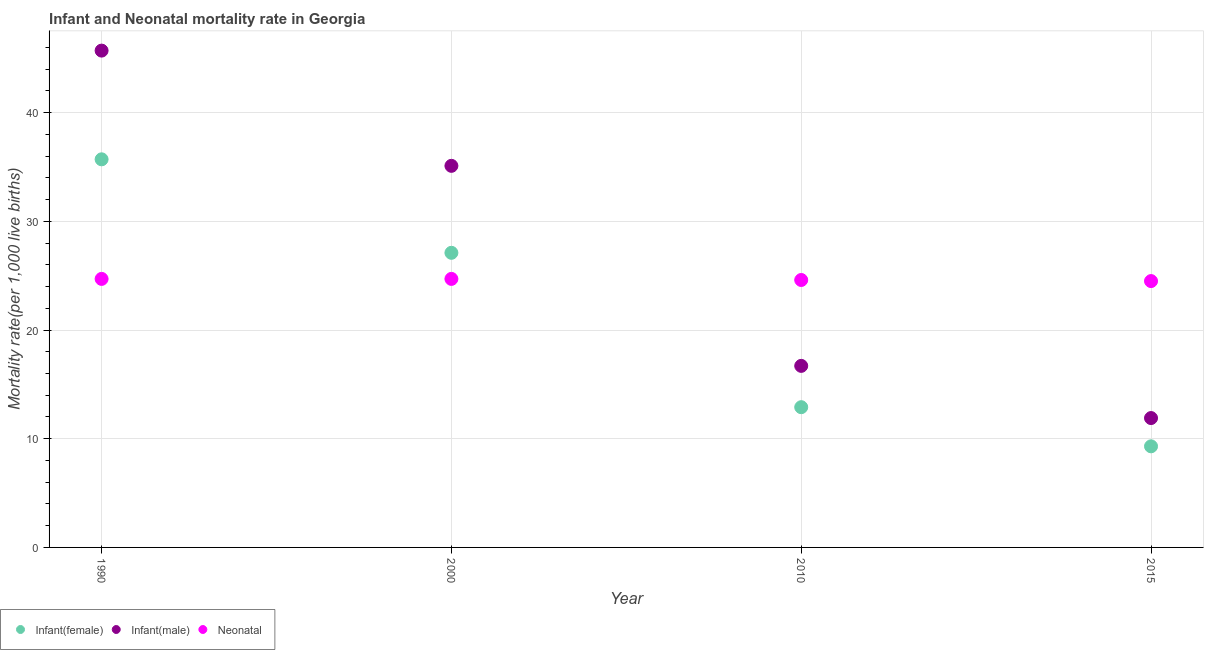Is the number of dotlines equal to the number of legend labels?
Your answer should be compact. Yes. What is the infant mortality rate(female) in 2000?
Give a very brief answer. 27.1. Across all years, what is the maximum neonatal mortality rate?
Offer a terse response. 24.7. In which year was the neonatal mortality rate minimum?
Provide a short and direct response. 2015. What is the total infant mortality rate(male) in the graph?
Ensure brevity in your answer.  109.4. What is the difference between the infant mortality rate(male) in 1990 and that in 2010?
Ensure brevity in your answer.  29. What is the difference between the neonatal mortality rate in 1990 and the infant mortality rate(female) in 2015?
Your answer should be compact. 15.4. What is the average infant mortality rate(male) per year?
Give a very brief answer. 27.35. In the year 1990, what is the difference between the infant mortality rate(male) and infant mortality rate(female)?
Offer a very short reply. 10. What is the ratio of the infant mortality rate(female) in 1990 to that in 2010?
Your response must be concise. 2.77. Is the infant mortality rate(female) in 2010 less than that in 2015?
Your answer should be very brief. No. What is the difference between the highest and the second highest infant mortality rate(female)?
Offer a very short reply. 8.6. What is the difference between the highest and the lowest infant mortality rate(female)?
Keep it short and to the point. 26.4. Is it the case that in every year, the sum of the infant mortality rate(female) and infant mortality rate(male) is greater than the neonatal mortality rate?
Give a very brief answer. No. Does the neonatal mortality rate monotonically increase over the years?
Keep it short and to the point. No. Is the infant mortality rate(female) strictly less than the infant mortality rate(male) over the years?
Offer a terse response. Yes. What is the difference between two consecutive major ticks on the Y-axis?
Keep it short and to the point. 10. Are the values on the major ticks of Y-axis written in scientific E-notation?
Make the answer very short. No. Does the graph contain any zero values?
Give a very brief answer. No. Where does the legend appear in the graph?
Provide a short and direct response. Bottom left. What is the title of the graph?
Provide a succinct answer. Infant and Neonatal mortality rate in Georgia. What is the label or title of the X-axis?
Provide a short and direct response. Year. What is the label or title of the Y-axis?
Give a very brief answer. Mortality rate(per 1,0 live births). What is the Mortality rate(per 1,000 live births) in Infant(female) in 1990?
Make the answer very short. 35.7. What is the Mortality rate(per 1,000 live births) in Infant(male) in 1990?
Your answer should be compact. 45.7. What is the Mortality rate(per 1,000 live births) in Neonatal  in 1990?
Your answer should be compact. 24.7. What is the Mortality rate(per 1,000 live births) in Infant(female) in 2000?
Your response must be concise. 27.1. What is the Mortality rate(per 1,000 live births) of Infant(male) in 2000?
Your answer should be very brief. 35.1. What is the Mortality rate(per 1,000 live births) in Neonatal  in 2000?
Your response must be concise. 24.7. What is the Mortality rate(per 1,000 live births) of Infant(female) in 2010?
Offer a terse response. 12.9. What is the Mortality rate(per 1,000 live births) in Infant(male) in 2010?
Provide a short and direct response. 16.7. What is the Mortality rate(per 1,000 live births) of Neonatal  in 2010?
Offer a very short reply. 24.6. What is the Mortality rate(per 1,000 live births) of Infant(male) in 2015?
Keep it short and to the point. 11.9. Across all years, what is the maximum Mortality rate(per 1,000 live births) of Infant(female)?
Your answer should be compact. 35.7. Across all years, what is the maximum Mortality rate(per 1,000 live births) in Infant(male)?
Ensure brevity in your answer.  45.7. Across all years, what is the maximum Mortality rate(per 1,000 live births) of Neonatal ?
Ensure brevity in your answer.  24.7. Across all years, what is the minimum Mortality rate(per 1,000 live births) in Infant(female)?
Give a very brief answer. 9.3. Across all years, what is the minimum Mortality rate(per 1,000 live births) of Infant(male)?
Keep it short and to the point. 11.9. What is the total Mortality rate(per 1,000 live births) in Infant(female) in the graph?
Provide a succinct answer. 85. What is the total Mortality rate(per 1,000 live births) in Infant(male) in the graph?
Your response must be concise. 109.4. What is the total Mortality rate(per 1,000 live births) of Neonatal  in the graph?
Offer a terse response. 98.5. What is the difference between the Mortality rate(per 1,000 live births) of Infant(female) in 1990 and that in 2010?
Make the answer very short. 22.8. What is the difference between the Mortality rate(per 1,000 live births) of Infant(male) in 1990 and that in 2010?
Ensure brevity in your answer.  29. What is the difference between the Mortality rate(per 1,000 live births) of Infant(female) in 1990 and that in 2015?
Ensure brevity in your answer.  26.4. What is the difference between the Mortality rate(per 1,000 live births) of Infant(male) in 1990 and that in 2015?
Your answer should be compact. 33.8. What is the difference between the Mortality rate(per 1,000 live births) in Infant(female) in 2000 and that in 2010?
Provide a short and direct response. 14.2. What is the difference between the Mortality rate(per 1,000 live births) in Infant(female) in 2000 and that in 2015?
Make the answer very short. 17.8. What is the difference between the Mortality rate(per 1,000 live births) of Infant(male) in 2000 and that in 2015?
Your answer should be compact. 23.2. What is the difference between the Mortality rate(per 1,000 live births) in Infant(male) in 2010 and that in 2015?
Offer a terse response. 4.8. What is the difference between the Mortality rate(per 1,000 live births) in Infant(female) in 1990 and the Mortality rate(per 1,000 live births) in Infant(male) in 2000?
Give a very brief answer. 0.6. What is the difference between the Mortality rate(per 1,000 live births) in Infant(female) in 1990 and the Mortality rate(per 1,000 live births) in Neonatal  in 2000?
Give a very brief answer. 11. What is the difference between the Mortality rate(per 1,000 live births) in Infant(female) in 1990 and the Mortality rate(per 1,000 live births) in Infant(male) in 2010?
Your response must be concise. 19. What is the difference between the Mortality rate(per 1,000 live births) of Infant(female) in 1990 and the Mortality rate(per 1,000 live births) of Neonatal  in 2010?
Your answer should be compact. 11.1. What is the difference between the Mortality rate(per 1,000 live births) of Infant(male) in 1990 and the Mortality rate(per 1,000 live births) of Neonatal  in 2010?
Provide a short and direct response. 21.1. What is the difference between the Mortality rate(per 1,000 live births) of Infant(female) in 1990 and the Mortality rate(per 1,000 live births) of Infant(male) in 2015?
Ensure brevity in your answer.  23.8. What is the difference between the Mortality rate(per 1,000 live births) in Infant(male) in 1990 and the Mortality rate(per 1,000 live births) in Neonatal  in 2015?
Offer a very short reply. 21.2. What is the difference between the Mortality rate(per 1,000 live births) in Infant(female) in 2000 and the Mortality rate(per 1,000 live births) in Infant(male) in 2010?
Make the answer very short. 10.4. What is the difference between the Mortality rate(per 1,000 live births) in Infant(female) in 2000 and the Mortality rate(per 1,000 live births) in Neonatal  in 2010?
Ensure brevity in your answer.  2.5. What is the difference between the Mortality rate(per 1,000 live births) of Infant(male) in 2010 and the Mortality rate(per 1,000 live births) of Neonatal  in 2015?
Offer a very short reply. -7.8. What is the average Mortality rate(per 1,000 live births) of Infant(female) per year?
Provide a succinct answer. 21.25. What is the average Mortality rate(per 1,000 live births) in Infant(male) per year?
Provide a succinct answer. 27.35. What is the average Mortality rate(per 1,000 live births) in Neonatal  per year?
Ensure brevity in your answer.  24.62. In the year 1990, what is the difference between the Mortality rate(per 1,000 live births) in Infant(female) and Mortality rate(per 1,000 live births) in Neonatal ?
Your response must be concise. 11. In the year 2000, what is the difference between the Mortality rate(per 1,000 live births) in Infant(female) and Mortality rate(per 1,000 live births) in Infant(male)?
Your response must be concise. -8. In the year 2010, what is the difference between the Mortality rate(per 1,000 live births) of Infant(female) and Mortality rate(per 1,000 live births) of Infant(male)?
Offer a very short reply. -3.8. In the year 2015, what is the difference between the Mortality rate(per 1,000 live births) in Infant(female) and Mortality rate(per 1,000 live births) in Infant(male)?
Provide a succinct answer. -2.6. In the year 2015, what is the difference between the Mortality rate(per 1,000 live births) of Infant(female) and Mortality rate(per 1,000 live births) of Neonatal ?
Give a very brief answer. -15.2. In the year 2015, what is the difference between the Mortality rate(per 1,000 live births) of Infant(male) and Mortality rate(per 1,000 live births) of Neonatal ?
Make the answer very short. -12.6. What is the ratio of the Mortality rate(per 1,000 live births) of Infant(female) in 1990 to that in 2000?
Give a very brief answer. 1.32. What is the ratio of the Mortality rate(per 1,000 live births) of Infant(male) in 1990 to that in 2000?
Your answer should be very brief. 1.3. What is the ratio of the Mortality rate(per 1,000 live births) in Neonatal  in 1990 to that in 2000?
Ensure brevity in your answer.  1. What is the ratio of the Mortality rate(per 1,000 live births) of Infant(female) in 1990 to that in 2010?
Offer a terse response. 2.77. What is the ratio of the Mortality rate(per 1,000 live births) in Infant(male) in 1990 to that in 2010?
Provide a short and direct response. 2.74. What is the ratio of the Mortality rate(per 1,000 live births) in Neonatal  in 1990 to that in 2010?
Your response must be concise. 1. What is the ratio of the Mortality rate(per 1,000 live births) of Infant(female) in 1990 to that in 2015?
Offer a terse response. 3.84. What is the ratio of the Mortality rate(per 1,000 live births) in Infant(male) in 1990 to that in 2015?
Your answer should be compact. 3.84. What is the ratio of the Mortality rate(per 1,000 live births) of Neonatal  in 1990 to that in 2015?
Offer a terse response. 1.01. What is the ratio of the Mortality rate(per 1,000 live births) of Infant(female) in 2000 to that in 2010?
Your answer should be compact. 2.1. What is the ratio of the Mortality rate(per 1,000 live births) in Infant(male) in 2000 to that in 2010?
Give a very brief answer. 2.1. What is the ratio of the Mortality rate(per 1,000 live births) of Neonatal  in 2000 to that in 2010?
Provide a short and direct response. 1. What is the ratio of the Mortality rate(per 1,000 live births) of Infant(female) in 2000 to that in 2015?
Offer a very short reply. 2.91. What is the ratio of the Mortality rate(per 1,000 live births) of Infant(male) in 2000 to that in 2015?
Provide a succinct answer. 2.95. What is the ratio of the Mortality rate(per 1,000 live births) of Neonatal  in 2000 to that in 2015?
Ensure brevity in your answer.  1.01. What is the ratio of the Mortality rate(per 1,000 live births) of Infant(female) in 2010 to that in 2015?
Keep it short and to the point. 1.39. What is the ratio of the Mortality rate(per 1,000 live births) of Infant(male) in 2010 to that in 2015?
Keep it short and to the point. 1.4. What is the ratio of the Mortality rate(per 1,000 live births) in Neonatal  in 2010 to that in 2015?
Your answer should be compact. 1. What is the difference between the highest and the second highest Mortality rate(per 1,000 live births) in Infant(female)?
Your answer should be compact. 8.6. What is the difference between the highest and the lowest Mortality rate(per 1,000 live births) of Infant(female)?
Ensure brevity in your answer.  26.4. What is the difference between the highest and the lowest Mortality rate(per 1,000 live births) of Infant(male)?
Make the answer very short. 33.8. What is the difference between the highest and the lowest Mortality rate(per 1,000 live births) in Neonatal ?
Ensure brevity in your answer.  0.2. 